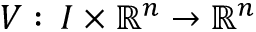Convert formula to latex. <formula><loc_0><loc_0><loc_500><loc_500>V \colon \, I \times \mathbb { R } ^ { n } \to \mathbb { R } ^ { n }</formula> 